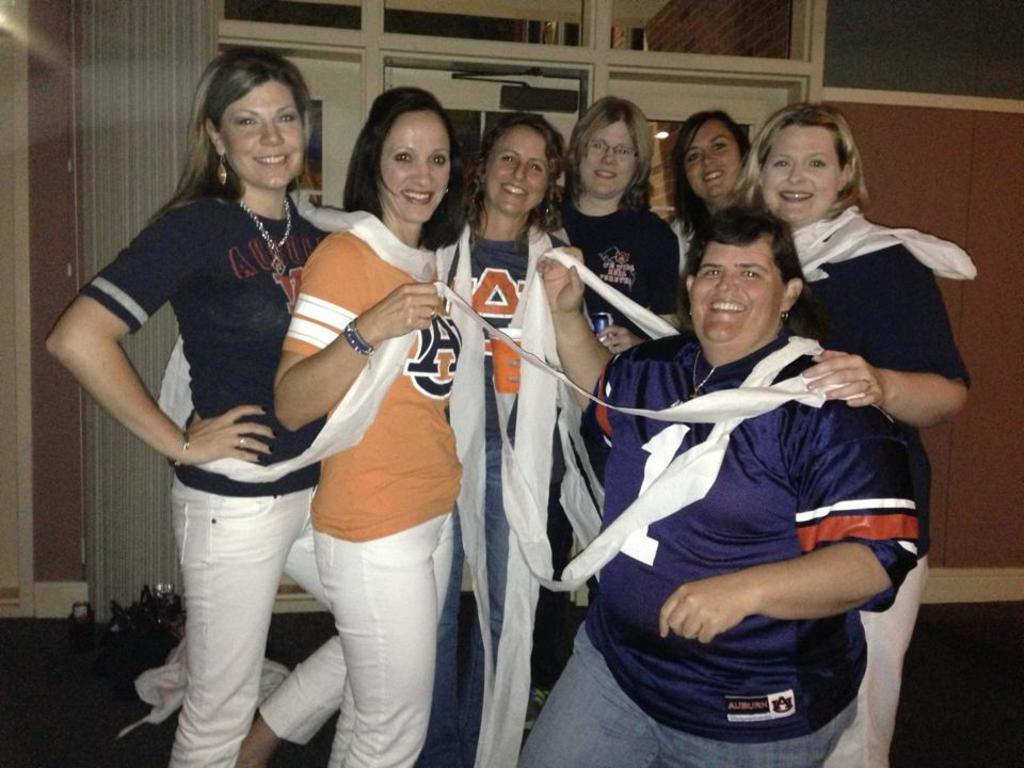How many people are in the image? There is a group of people in the image. What can be observed about the clothing of the people in the image? The people are wearing different color dresses. What can be seen in the background of the image? There is a curtain and a poster attached to a wall in the background of the image. What type of hearing aid is the person in the middle of the group wearing? There is no indication of a hearing aid or any person wearing one in the image. 